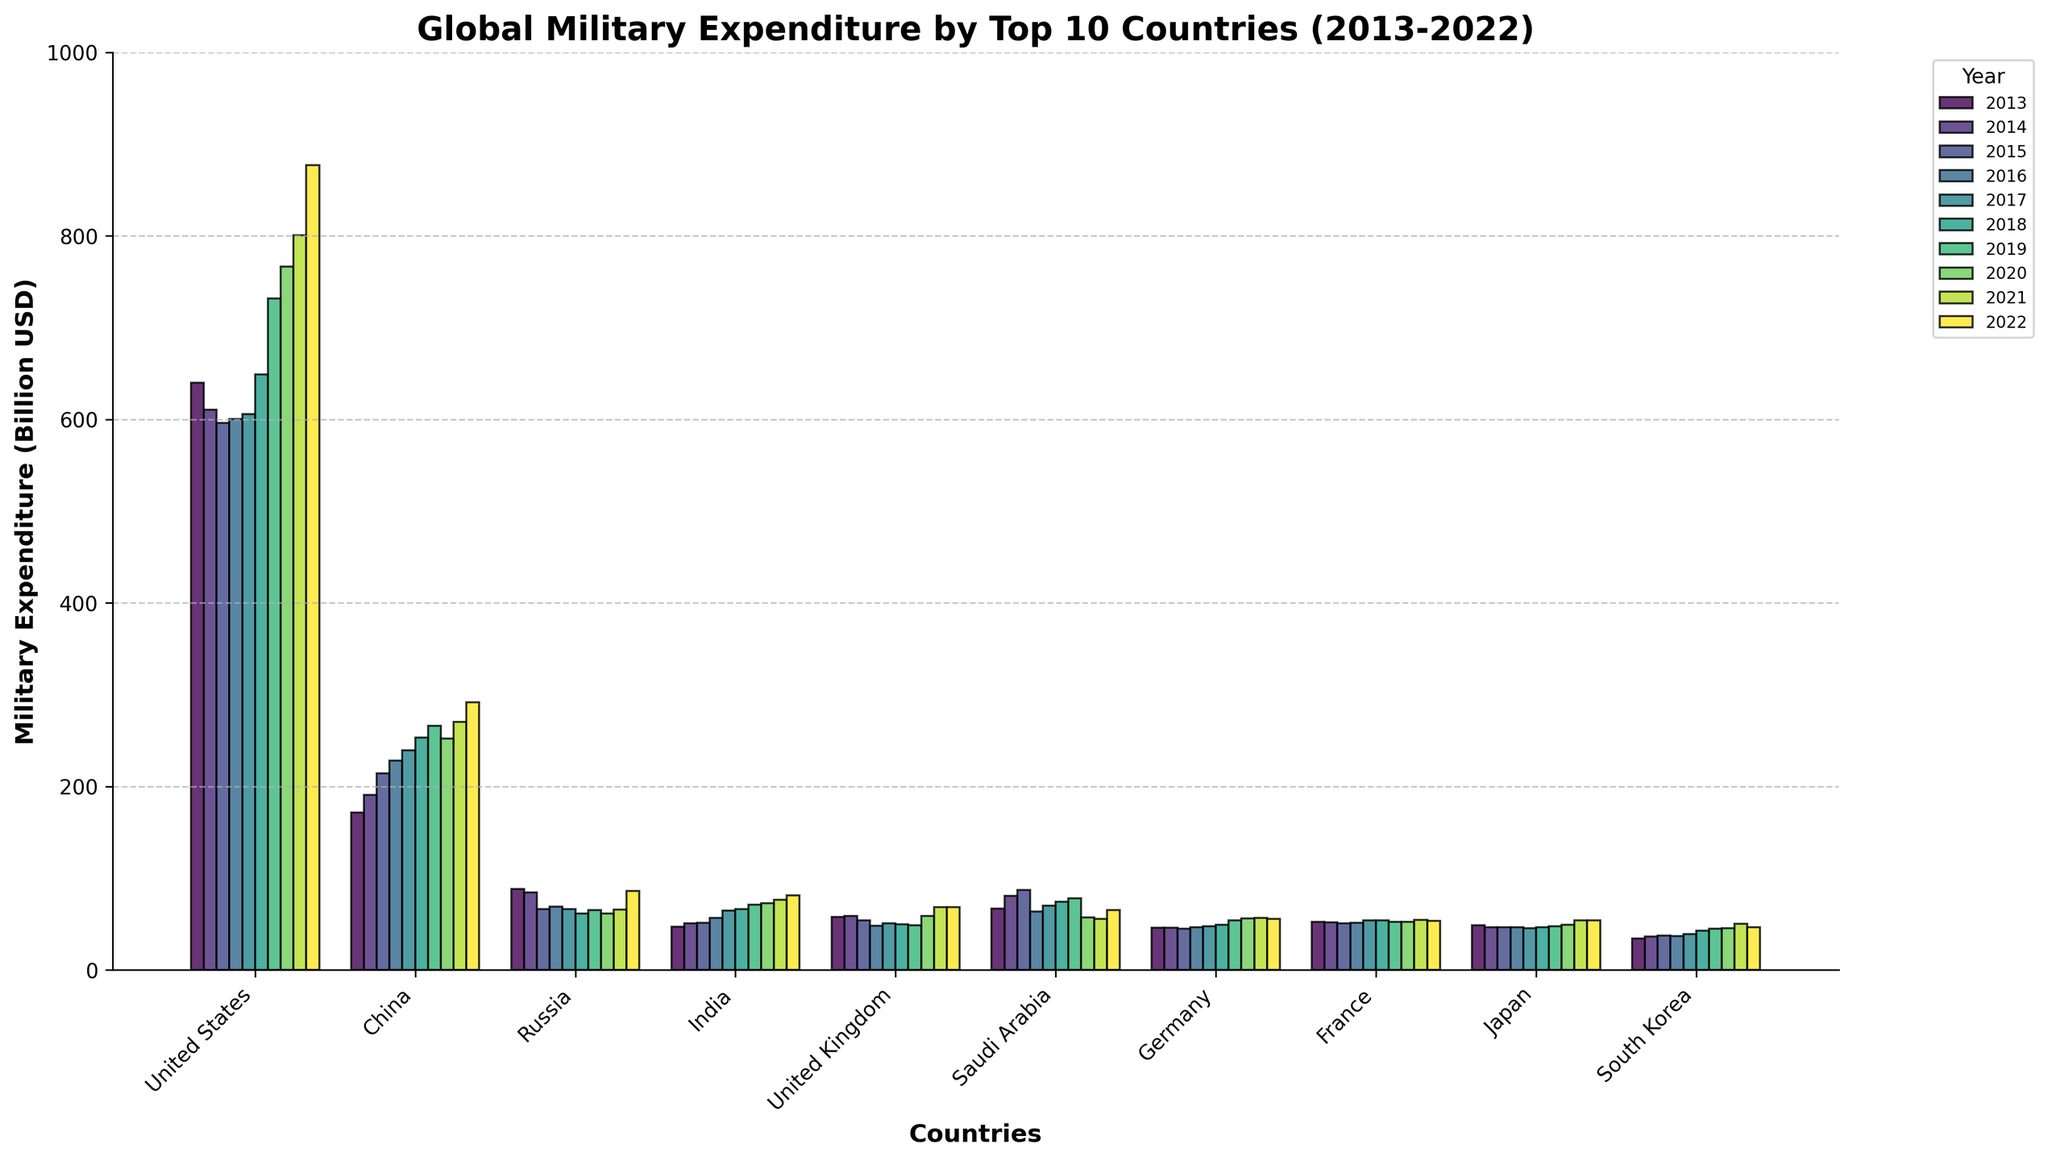Which country had the highest military expenditure in 2022? Look at the height of the bars for the year 2022. The United States has the tallest bar.
Answer: United States Which two countries had the largest increase in military expenditure from 2013 to 2022? Compare the heights of the bars for 2013 and 2022 for each country. The United States and China have the largest increases.
Answer: United States and China What is the combined military expenditure of the United Kingdom and Japan in 2021? Add the heights of the bars for the United Kingdom and Japan in 2021. UK: 68.4, Japan: 54.1. Combined: 68.4 + 54.1 = 122.5.
Answer: 122.5 In which year did Russia have the lowest military expenditure? Find the year with the shortest bar for Russia. It is 2017.
Answer: 2017 By how much did India's military expenditure increase from 2015 to 2022? Subtract the height of the bar for 2015 from the height of the bar for 2022 for India. 81.4 - 51.3.
Answer: 30.1 Which country had the smallest military expenditure in 2013? Look for the shortest bar in 2013. South Korea's bar is the shortest.
Answer: South Korea What is the average military expenditure of China over the decade? Sum the heights of the bars for China from 2013 to 2022 and divide by 10: (171.4 + 190.9 + 214.1 + 228.2 + 239.2 + 253.1 + 266.4 + 252.3 + 270.4 + 292.0) / 10 = 237.8.
Answer: 237.8 Which year shows the highest expenditure for Saudi Arabia, and how much is it? Look at the tallest bar for Saudi Arabia and note the year. The tallest bar is in 2015 with 87.2.
Answer: 2015, 87.2 Compare the military expenditures of Germany and France in 2018. Which country spent more? Compare the heights of the bars for Germany and France in 2018. Germany's bar is slightly higher.
Answer: Germany What is the total military expenditure of the top 10 countries in 2020? Sum the heights of all bars for the year 2020: 766.6 + 252.3 + 61.7 + 72.9 + 59.2 + 57.5 + 56.1 + 52.7 + 49.1 + 45.7 = 1473.8.
Answer: 1473.8 